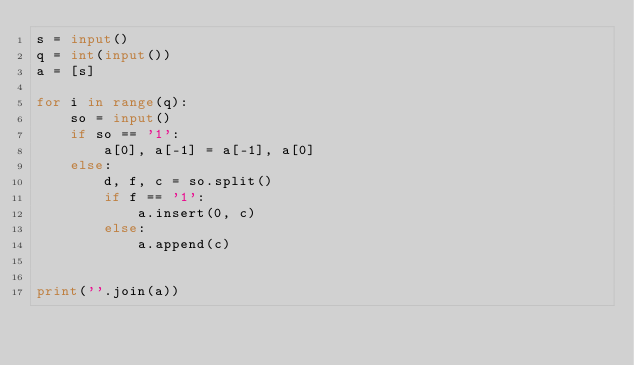<code> <loc_0><loc_0><loc_500><loc_500><_Python_>s = input()
q = int(input())
a = [s]

for i in range(q):
    so = input()
    if so == '1':
        a[0], a[-1] = a[-1], a[0]
    else:
        d, f, c = so.split()
        if f == '1':
            a.insert(0, c)
        else:
            a.append(c)


print(''.join(a))
</code> 